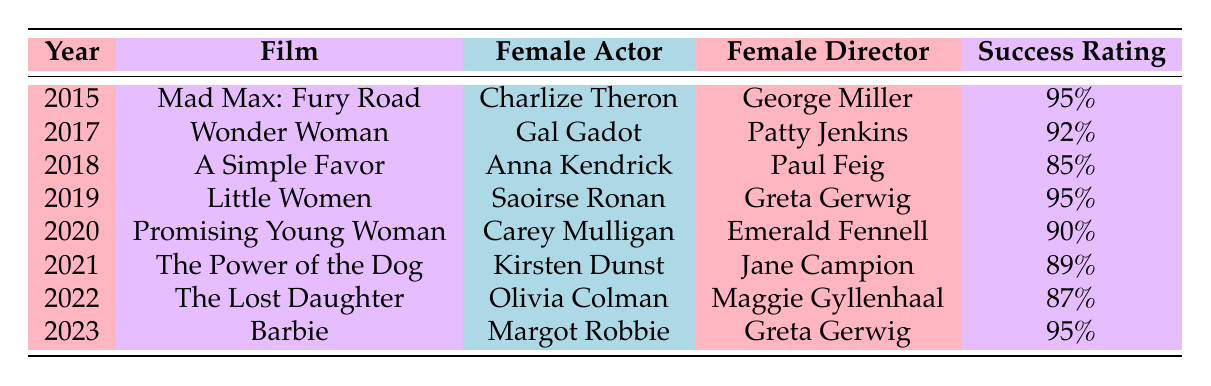What is the film with the highest success rating? The highest success rating in the table is 95%, which appears for two films: "Mad Max: Fury Road" and "Little Women." Therefore, both film titles are correct answers.
Answer: Mad Max: Fury Road, Little Women Which film was directed by a female director in 2022? From the table, in 2022, "The Lost Daughter" is listed, and it was directed by Maggie Gyllenhaal.
Answer: The Lost Daughter How many films have a success rating of 90% or higher? The success ratings of the films listed are 95%, 92%, 85%, 95%, 90%, 89%, 87%, and 95%. Counting those with 90% or above: Mad Max: Fury Road, Wonder Woman, Little Women, Promising Young Woman, and Barbie gives a total of five films.
Answer: 5 Was there a film featuring a female actor directed by a female director in 2018? The film in 2018 is "A Simple Favor," and it was directed by Paul Feig, a male director. Therefore, the statement is false.
Answer: No What is the average success rating of films released from 2015 to 2023? The success ratings are 95%, 92%, 85%, 95%, 90%, 89%, 87%, and 95%. First, we sum these ratings: 95 + 92 + 85 + 95 + 90 + 89 + 87 + 95 = 733. Then we divide this total by the number of films (8): 733 / 8 = 91.625. The average success rating is approximately 91.63%.
Answer: 91.63% Which female actor worked with the same female director on two different films? Greta Gerwig directed both "Little Women" in 2019 and "Barbie" in 2023, featuring Saoirse Ronan and Margot Robbie, respectively. However, these are different actors, so no individual actor pairs with the same director on two different films in the dataset.
Answer: No What is the difference in success ratings between the highest-rated and lowest-rated films? The highest success rating is 95% from "Mad Max: Fury Road," "Little Women," and "Barbie." The lowest rating is 85% from "A Simple Favor." The difference is calculated as 95% - 85% = 10%.
Answer: 10% Did all the films from 2015 to 2023 feature female actors? Looking at the table, all films listed feature female actors. Therefore, the statement is true.
Answer: Yes 